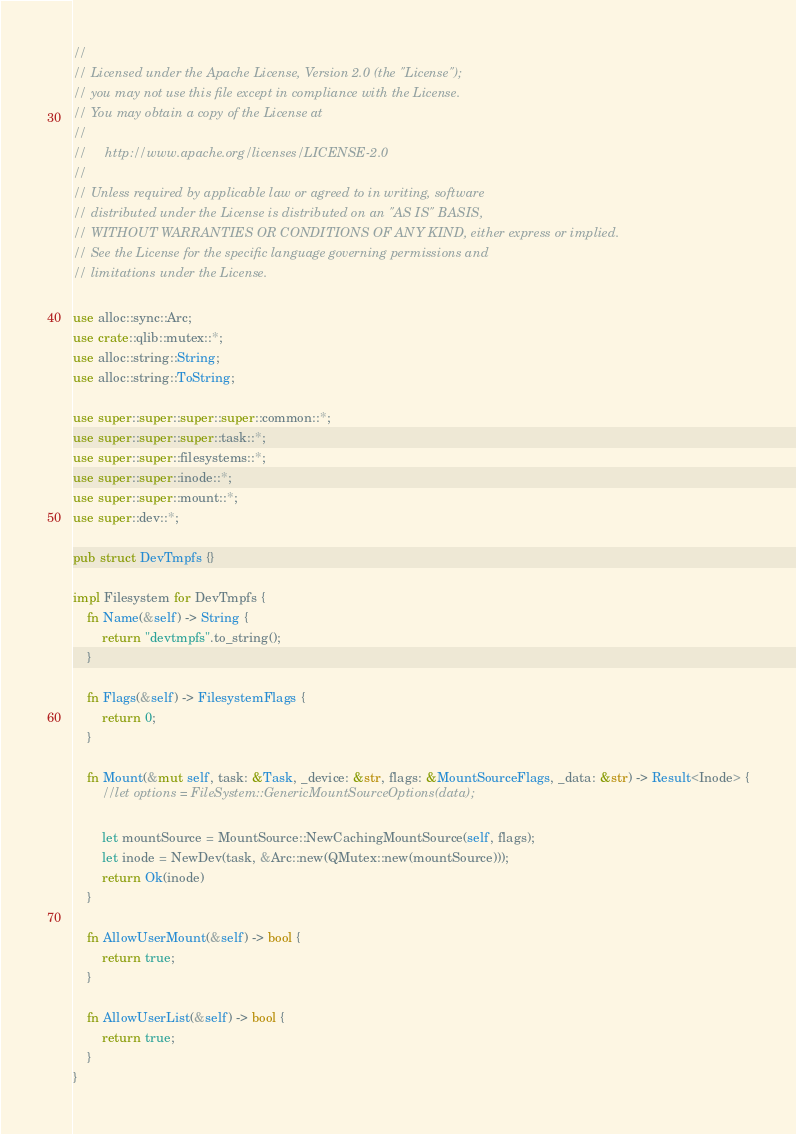Convert code to text. <code><loc_0><loc_0><loc_500><loc_500><_Rust_>//
// Licensed under the Apache License, Version 2.0 (the "License");
// you may not use this file except in compliance with the License.
// You may obtain a copy of the License at
//
//     http://www.apache.org/licenses/LICENSE-2.0
//
// Unless required by applicable law or agreed to in writing, software
// distributed under the License is distributed on an "AS IS" BASIS,
// WITHOUT WARRANTIES OR CONDITIONS OF ANY KIND, either express or implied.
// See the License for the specific language governing permissions and
// limitations under the License.

use alloc::sync::Arc;
use crate::qlib::mutex::*;
use alloc::string::String;
use alloc::string::ToString;

use super::super::super::super::common::*;
use super::super::super::task::*;
use super::super::filesystems::*;
use super::super::inode::*;
use super::super::mount::*;
use super::dev::*;

pub struct DevTmpfs {}

impl Filesystem for DevTmpfs {
    fn Name(&self) -> String {
        return "devtmpfs".to_string();
    }

    fn Flags(&self) -> FilesystemFlags {
        return 0;
    }

    fn Mount(&mut self, task: &Task, _device: &str, flags: &MountSourceFlags, _data: &str) -> Result<Inode> {
        //let options = FileSystem::GenericMountSourceOptions(data);

        let mountSource = MountSource::NewCachingMountSource(self, flags);
        let inode = NewDev(task, &Arc::new(QMutex::new(mountSource)));
        return Ok(inode)
    }

    fn AllowUserMount(&self) -> bool {
        return true;
    }

    fn AllowUserList(&self) -> bool {
        return true;
    }
}</code> 